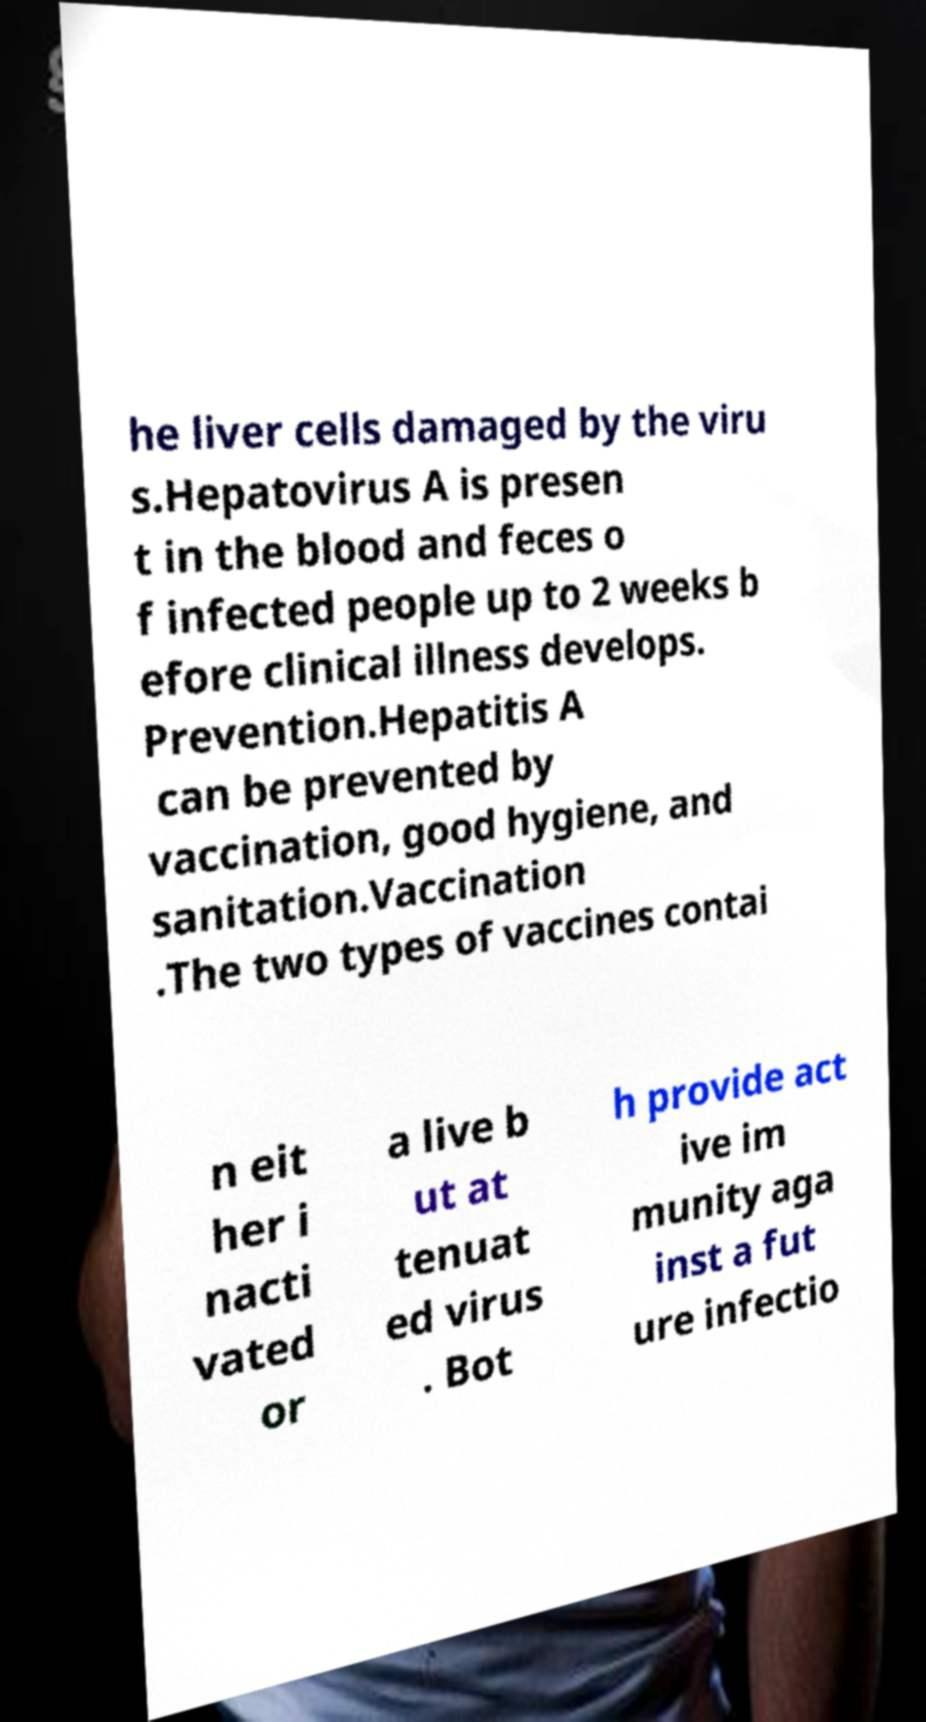Could you assist in decoding the text presented in this image and type it out clearly? he liver cells damaged by the viru s.Hepatovirus A is presen t in the blood and feces o f infected people up to 2 weeks b efore clinical illness develops. Prevention.Hepatitis A can be prevented by vaccination, good hygiene, and sanitation.Vaccination .The two types of vaccines contai n eit her i nacti vated or a live b ut at tenuat ed virus . Bot h provide act ive im munity aga inst a fut ure infectio 